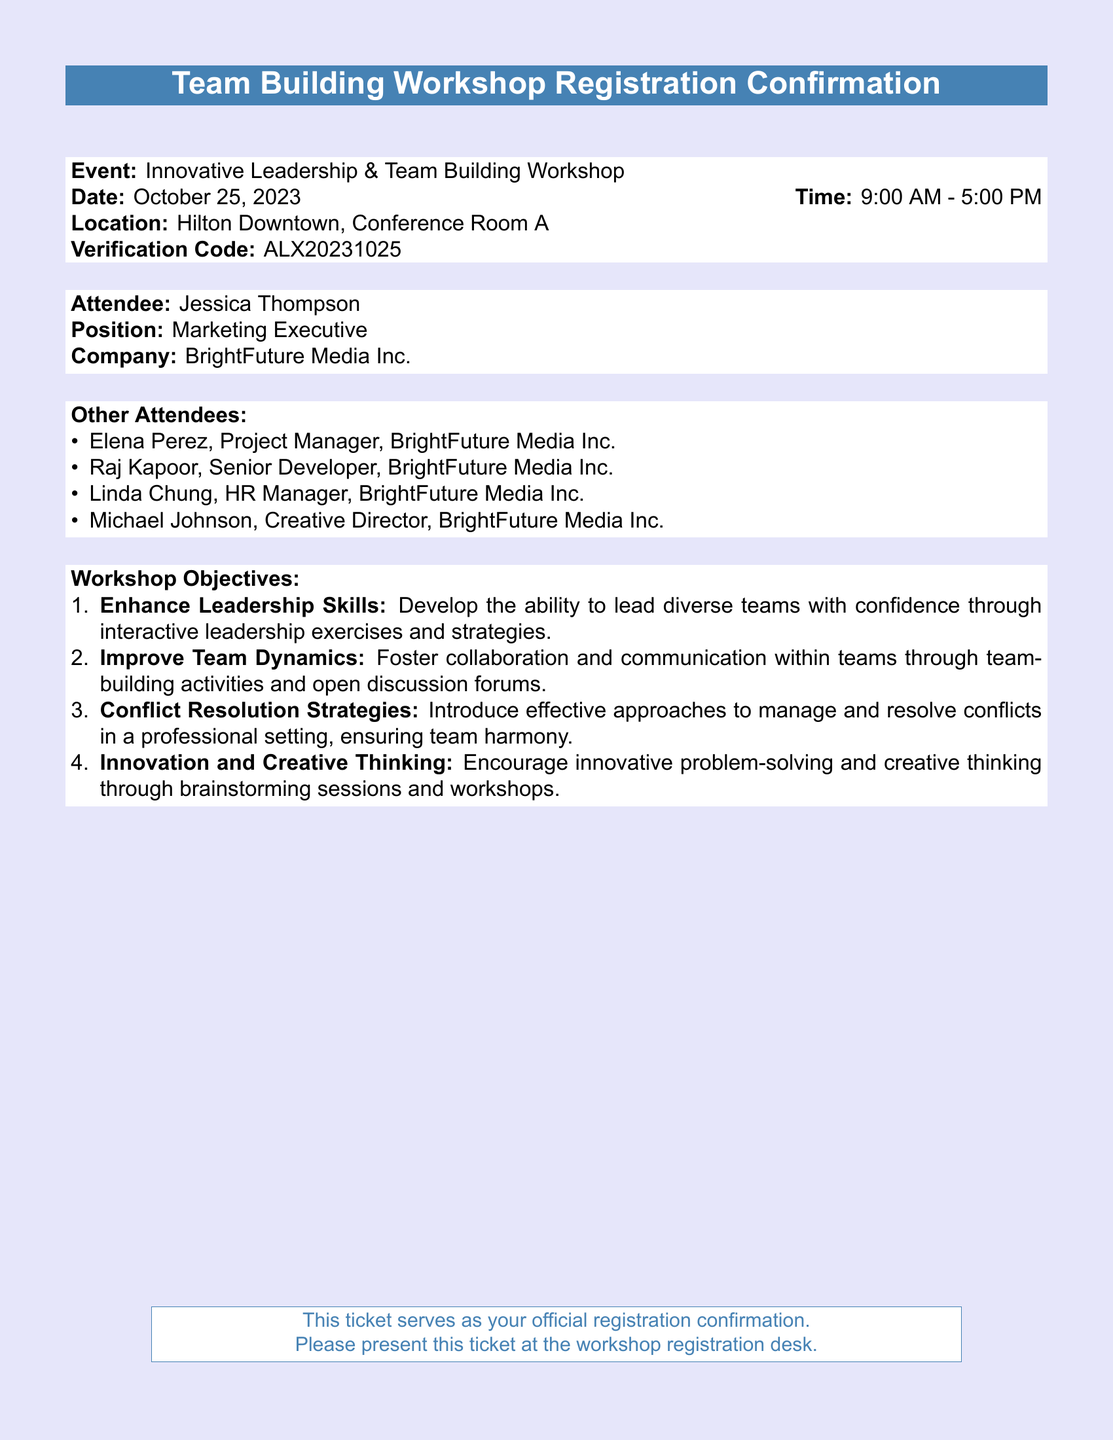What is the date of the workshop? The date of the workshop is specified in the document, which reads October 25, 2023.
Answer: October 25, 2023 What is the verification code for registration? The verification code is mentioned in the event details section of the document as ALX20231025.
Answer: ALX20231025 Who is the Marketing Executive attending the workshop? The document lists Jessica Thompson as the Marketing Executive attending the workshop.
Answer: Jessica Thompson How many other attendees are listed in the document? The document includes a list of other attendees, which totals five, including the main attendee.
Answer: 5 What are the workshop objectives focused on? The objectives focus on enhancing leadership skills, improving team dynamics, conflict resolution strategies, and innovation along with creative thinking.
Answer: Leadership skills, team dynamics, conflict resolution, innovation What time does the workshop start? The document states the workshop starts at 9:00 AM.
Answer: 9:00 AM What is the location of the workshop? The location of the workshop is specified in the document as Hilton Downtown, Conference Room A.
Answer: Hilton Downtown, Conference Room A Which company is Jessica Thompson associated with? The document indicates that Jessica Thompson is associated with BrightFuture Media Inc.
Answer: BrightFuture Media Inc 